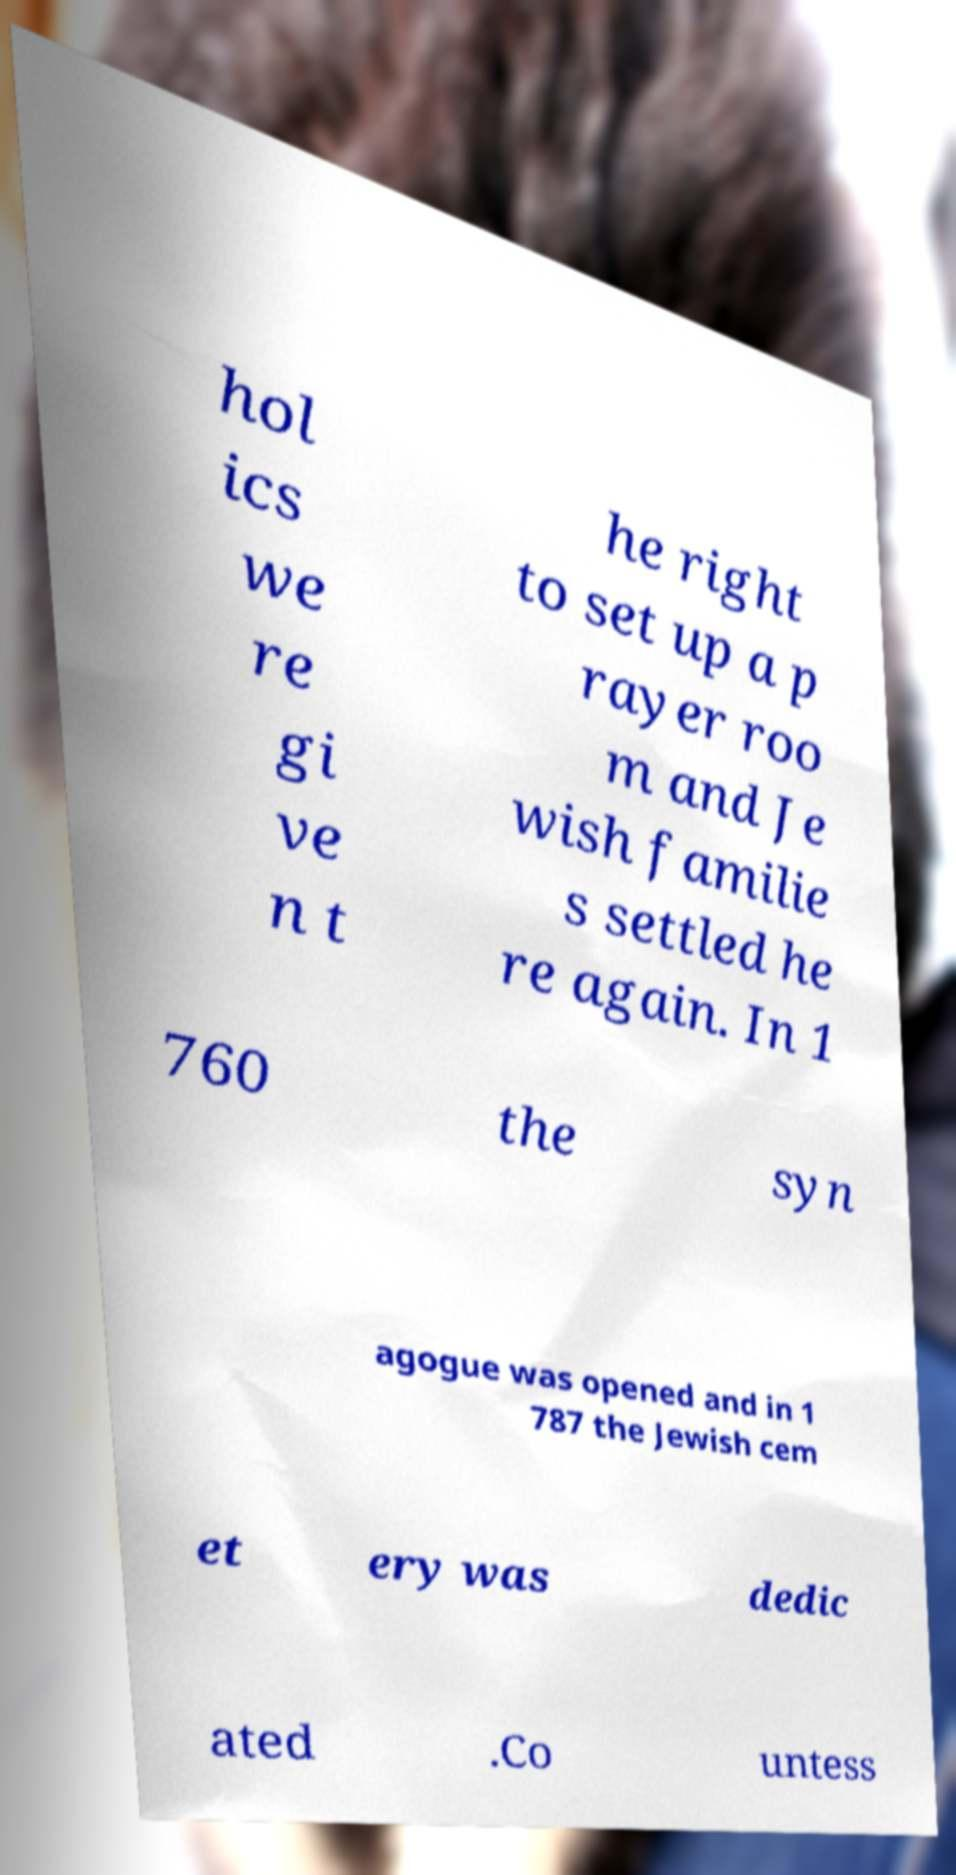Can you accurately transcribe the text from the provided image for me? hol ics we re gi ve n t he right to set up a p rayer roo m and Je wish familie s settled he re again. In 1 760 the syn agogue was opened and in 1 787 the Jewish cem et ery was dedic ated .Co untess 